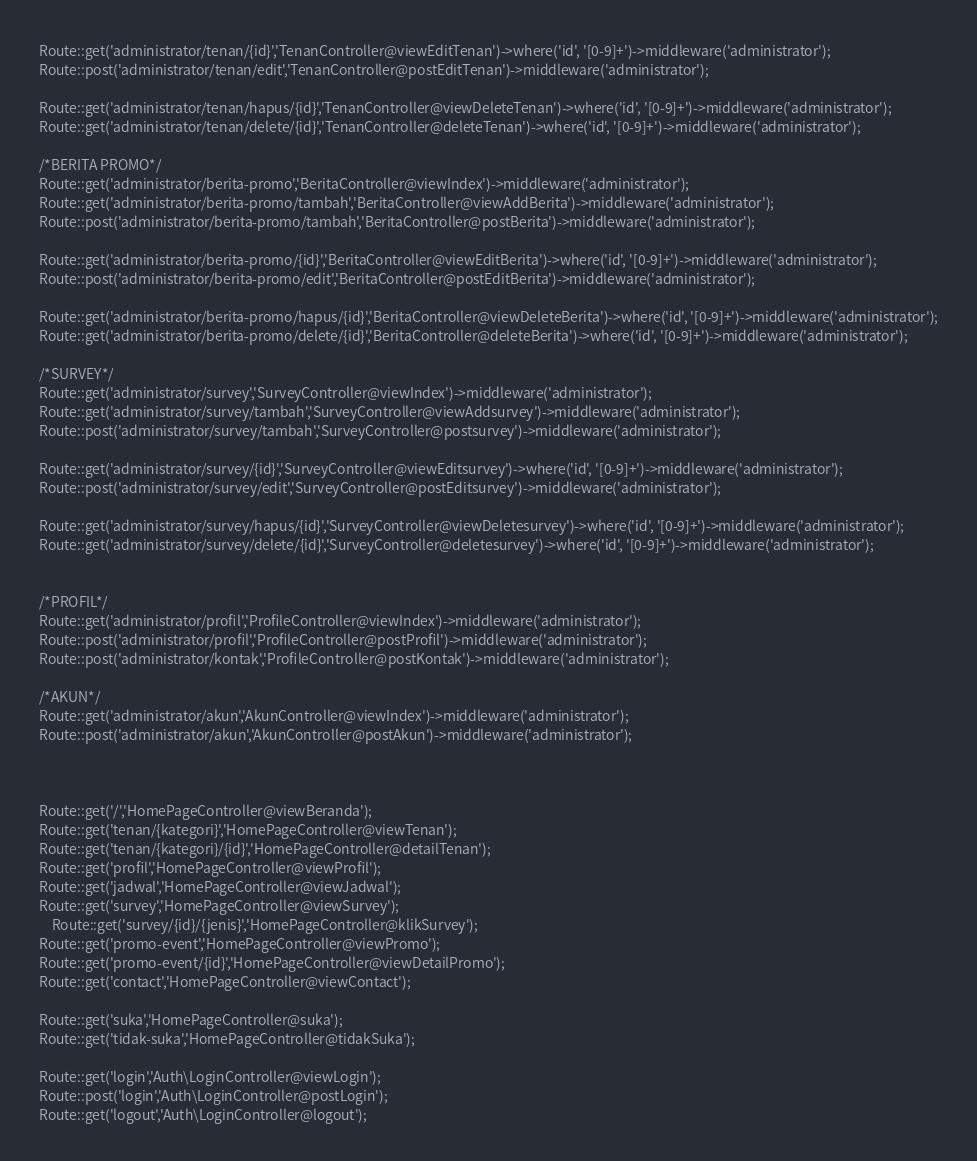<code> <loc_0><loc_0><loc_500><loc_500><_PHP_>Route::get('administrator/tenan/{id}','TenanController@viewEditTenan')->where('id', '[0-9]+')->middleware('administrator');
Route::post('administrator/tenan/edit','TenanController@postEditTenan')->middleware('administrator');

Route::get('administrator/tenan/hapus/{id}','TenanController@viewDeleteTenan')->where('id', '[0-9]+')->middleware('administrator');
Route::get('administrator/tenan/delete/{id}','TenanController@deleteTenan')->where('id', '[0-9]+')->middleware('administrator');

/*BERITA PROMO*/
Route::get('administrator/berita-promo','BeritaController@viewIndex')->middleware('administrator');
Route::get('administrator/berita-promo/tambah','BeritaController@viewAddBerita')->middleware('administrator');
Route::post('administrator/berita-promo/tambah','BeritaController@postBerita')->middleware('administrator');

Route::get('administrator/berita-promo/{id}','BeritaController@viewEditBerita')->where('id', '[0-9]+')->middleware('administrator');
Route::post('administrator/berita-promo/edit','BeritaController@postEditBerita')->middleware('administrator');

Route::get('administrator/berita-promo/hapus/{id}','BeritaController@viewDeleteBerita')->where('id', '[0-9]+')->middleware('administrator');
Route::get('administrator/berita-promo/delete/{id}','BeritaController@deleteBerita')->where('id', '[0-9]+')->middleware('administrator');

/*SURVEY*/
Route::get('administrator/survey','SurveyController@viewIndex')->middleware('administrator');
Route::get('administrator/survey/tambah','SurveyController@viewAddsurvey')->middleware('administrator');
Route::post('administrator/survey/tambah','SurveyController@postsurvey')->middleware('administrator');

Route::get('administrator/survey/{id}','SurveyController@viewEditsurvey')->where('id', '[0-9]+')->middleware('administrator');
Route::post('administrator/survey/edit','SurveyController@postEditsurvey')->middleware('administrator');

Route::get('administrator/survey/hapus/{id}','SurveyController@viewDeletesurvey')->where('id', '[0-9]+')->middleware('administrator');
Route::get('administrator/survey/delete/{id}','SurveyController@deletesurvey')->where('id', '[0-9]+')->middleware('administrator');


/*PROFIL*/
Route::get('administrator/profil','ProfileController@viewIndex')->middleware('administrator');
Route::post('administrator/profil','ProfileController@postProfil')->middleware('administrator');
Route::post('administrator/kontak','ProfileController@postKontak')->middleware('administrator');

/*AKUN*/
Route::get('administrator/akun','AkunController@viewIndex')->middleware('administrator');
Route::post('administrator/akun','AkunController@postAkun')->middleware('administrator');



Route::get('/','HomePageController@viewBeranda');
Route::get('tenan/{kategori}','HomePageController@viewTenan');
Route::get('tenan/{kategori}/{id}','HomePageController@detailTenan');
Route::get('profil','HomePageController@viewProfil');
Route::get('jadwal','HomePageController@viewJadwal');
Route::get('survey','HomePageController@viewSurvey');
	Route::get('survey/{id}/{jenis}','HomePageController@klikSurvey');
Route::get('promo-event','HomePageController@viewPromo');
Route::get('promo-event/{id}','HomePageController@viewDetailPromo');
Route::get('contact','HomePageController@viewContact');

Route::get('suka','HomePageController@suka');
Route::get('tidak-suka','HomePageController@tidakSuka');

Route::get('login','Auth\LoginController@viewLogin');
Route::post('login','Auth\LoginController@postLogin');
Route::get('logout','Auth\LoginController@logout');</code> 